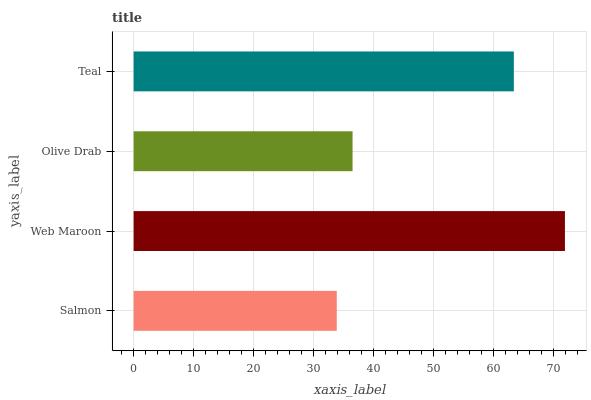Is Salmon the minimum?
Answer yes or no. Yes. Is Web Maroon the maximum?
Answer yes or no. Yes. Is Olive Drab the minimum?
Answer yes or no. No. Is Olive Drab the maximum?
Answer yes or no. No. Is Web Maroon greater than Olive Drab?
Answer yes or no. Yes. Is Olive Drab less than Web Maroon?
Answer yes or no. Yes. Is Olive Drab greater than Web Maroon?
Answer yes or no. No. Is Web Maroon less than Olive Drab?
Answer yes or no. No. Is Teal the high median?
Answer yes or no. Yes. Is Olive Drab the low median?
Answer yes or no. Yes. Is Salmon the high median?
Answer yes or no. No. Is Web Maroon the low median?
Answer yes or no. No. 